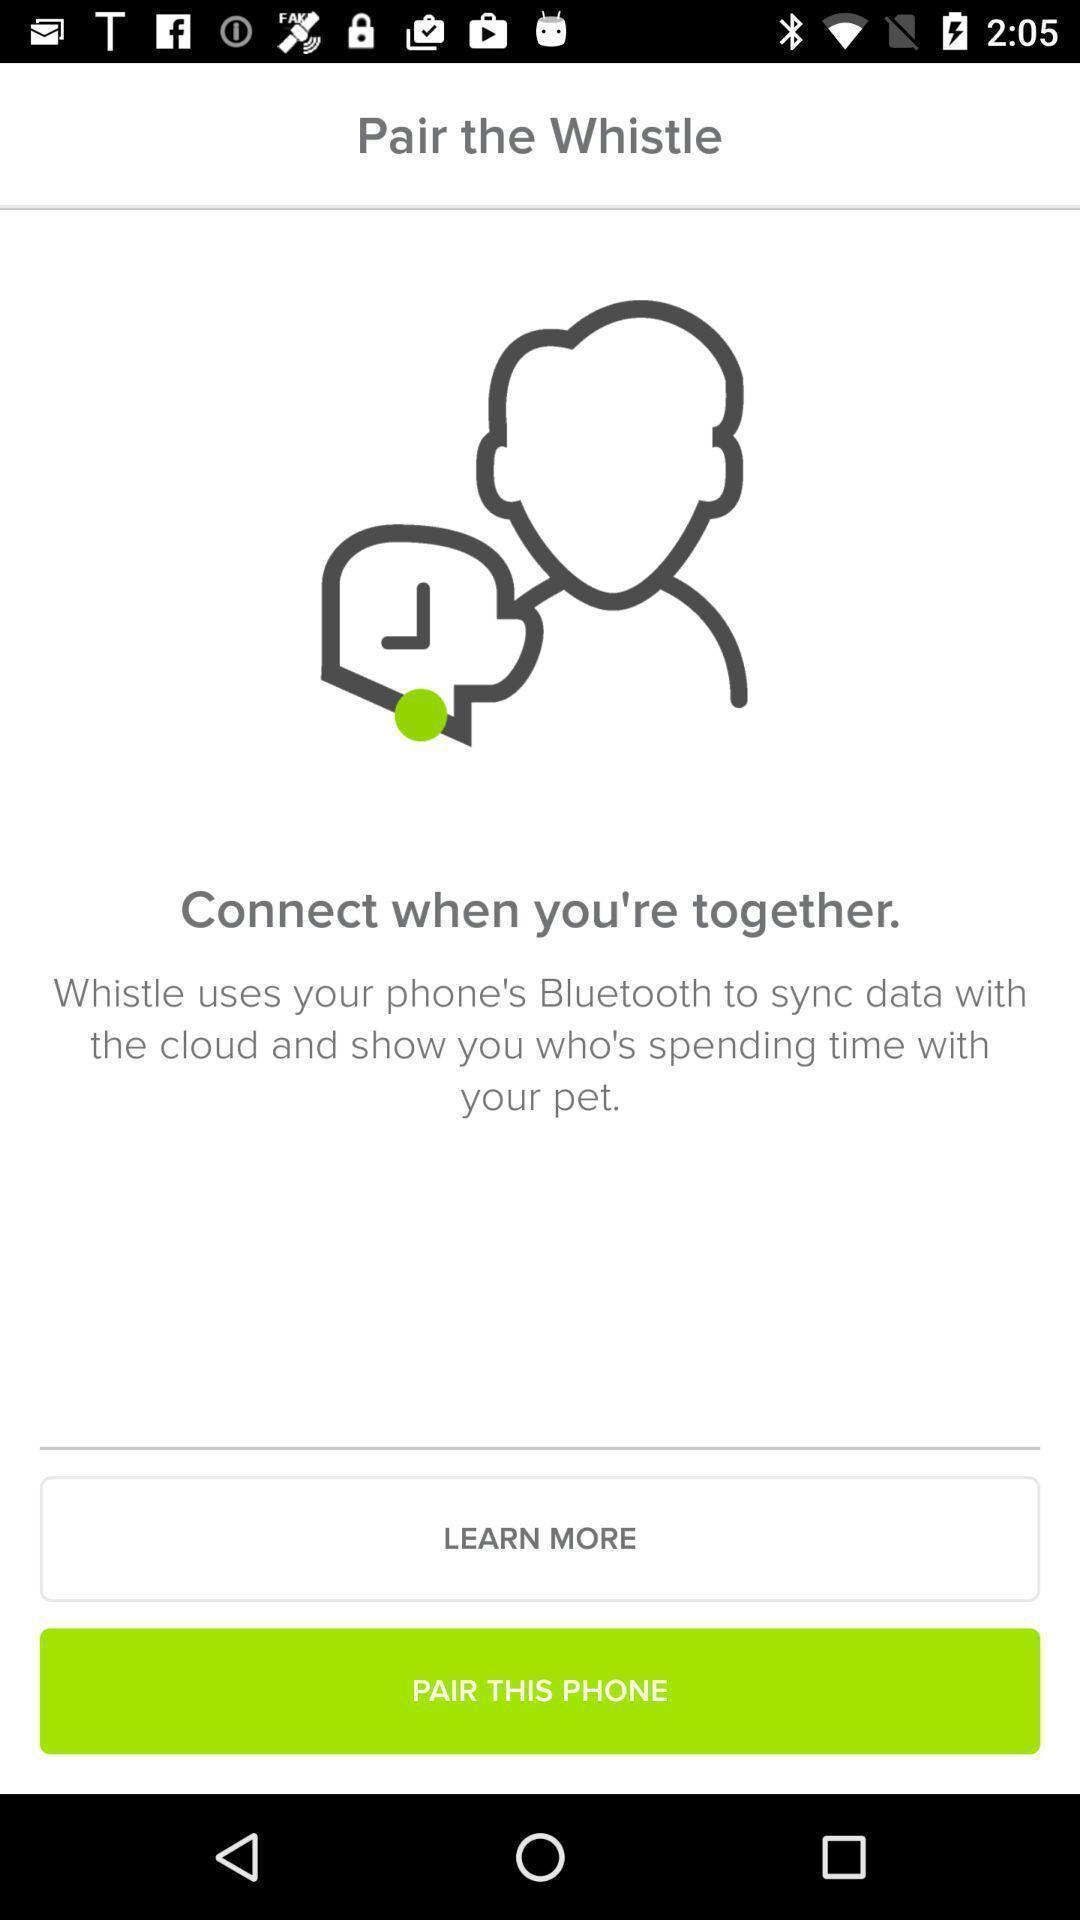Explain what's happening in this screen capture. Window displaying a pet care app. 